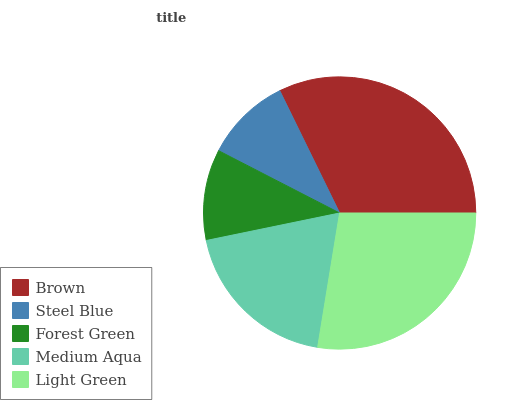Is Steel Blue the minimum?
Answer yes or no. Yes. Is Brown the maximum?
Answer yes or no. Yes. Is Forest Green the minimum?
Answer yes or no. No. Is Forest Green the maximum?
Answer yes or no. No. Is Forest Green greater than Steel Blue?
Answer yes or no. Yes. Is Steel Blue less than Forest Green?
Answer yes or no. Yes. Is Steel Blue greater than Forest Green?
Answer yes or no. No. Is Forest Green less than Steel Blue?
Answer yes or no. No. Is Medium Aqua the high median?
Answer yes or no. Yes. Is Medium Aqua the low median?
Answer yes or no. Yes. Is Light Green the high median?
Answer yes or no. No. Is Light Green the low median?
Answer yes or no. No. 